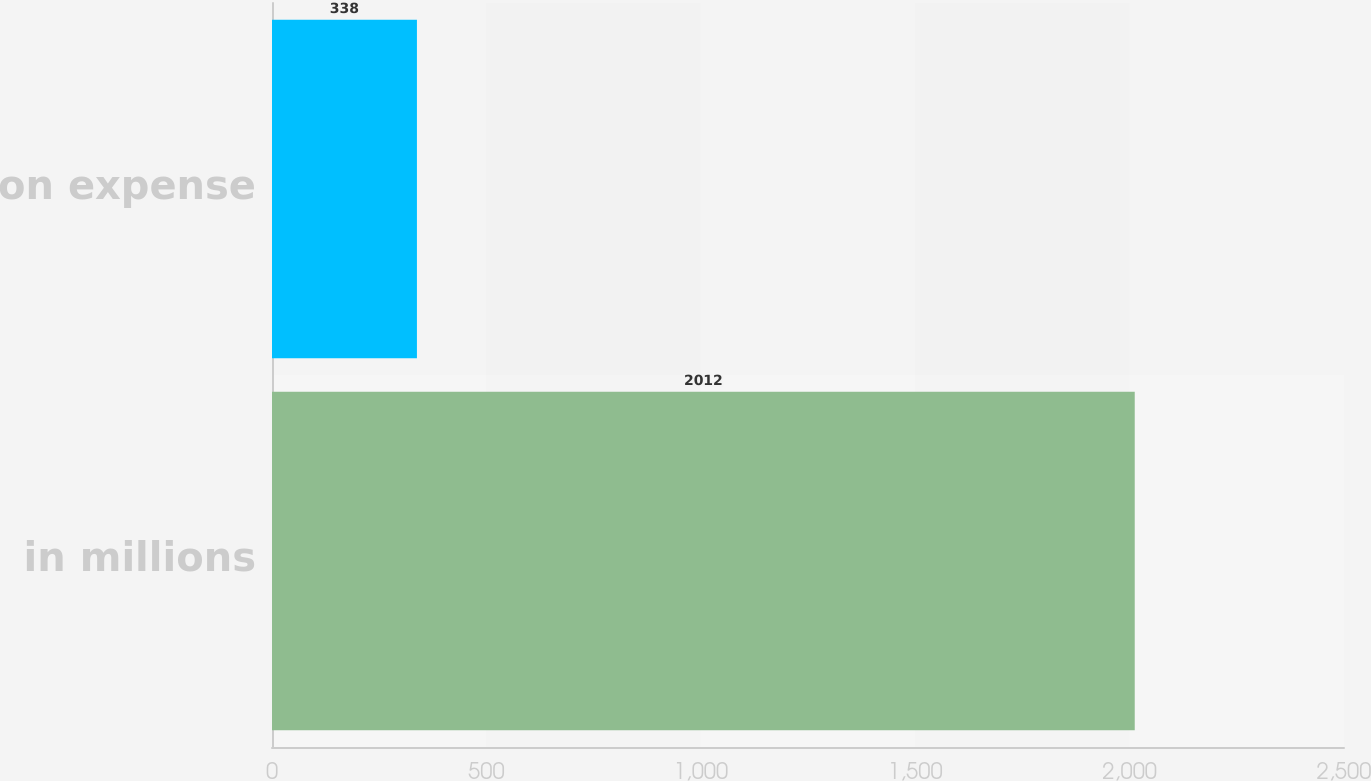Convert chart to OTSL. <chart><loc_0><loc_0><loc_500><loc_500><bar_chart><fcel>in millions<fcel>Amortization expense<nl><fcel>2012<fcel>338<nl></chart> 